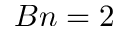<formula> <loc_0><loc_0><loc_500><loc_500>B n = 2</formula> 